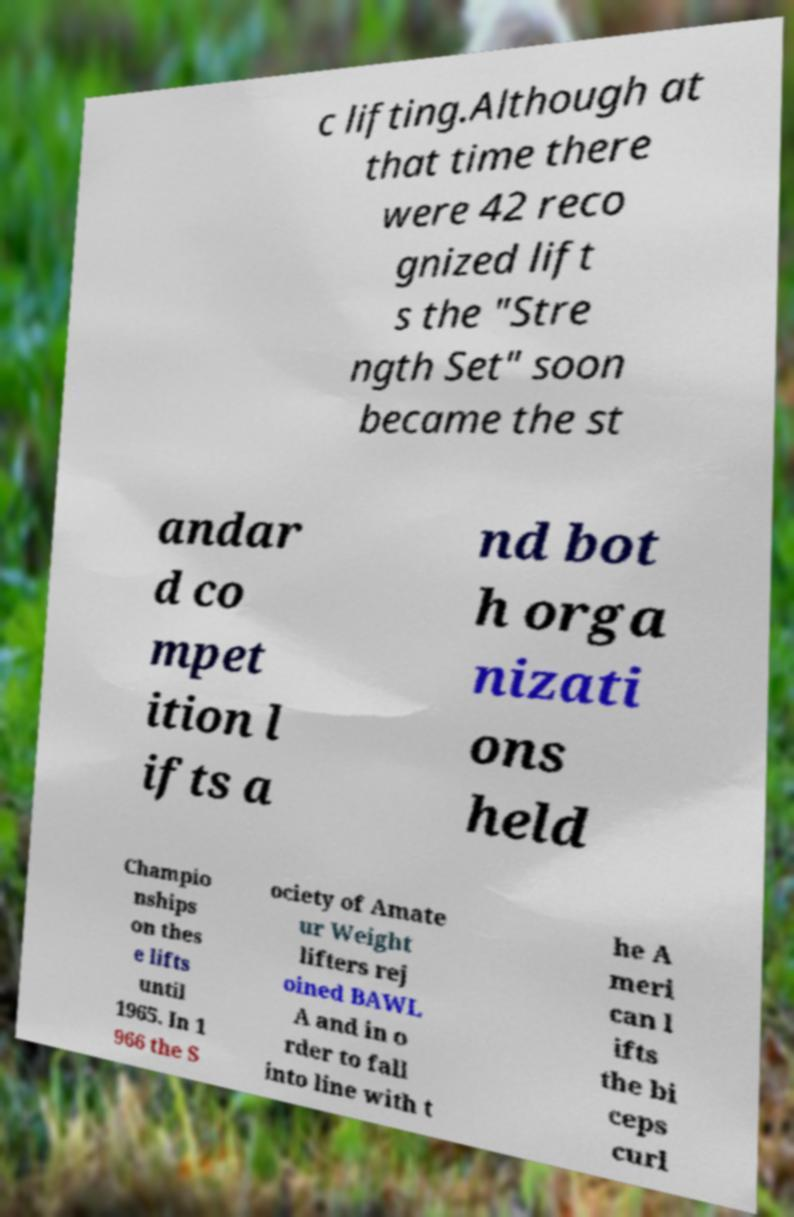What messages or text are displayed in this image? I need them in a readable, typed format. c lifting.Although at that time there were 42 reco gnized lift s the "Stre ngth Set" soon became the st andar d co mpet ition l ifts a nd bot h orga nizati ons held Champio nships on thes e lifts until 1965. In 1 966 the S ociety of Amate ur Weight lifters rej oined BAWL A and in o rder to fall into line with t he A meri can l ifts the bi ceps curl 